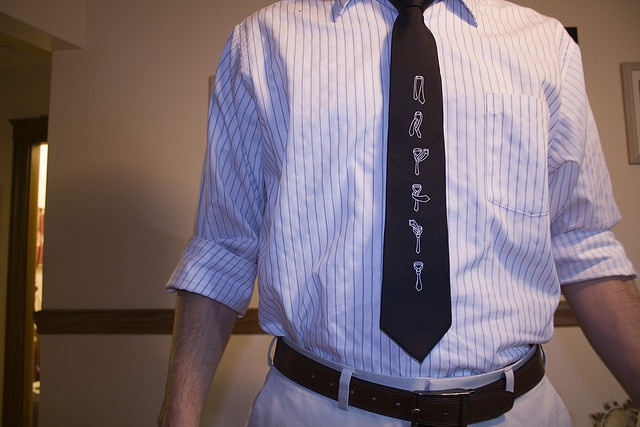Describe the objects in this image and their specific colors. I can see people in black, lightgray, gray, and darkgray tones, tie in black, gray, and darkgray tones, and toilet in black, maroon, and tan tones in this image. 